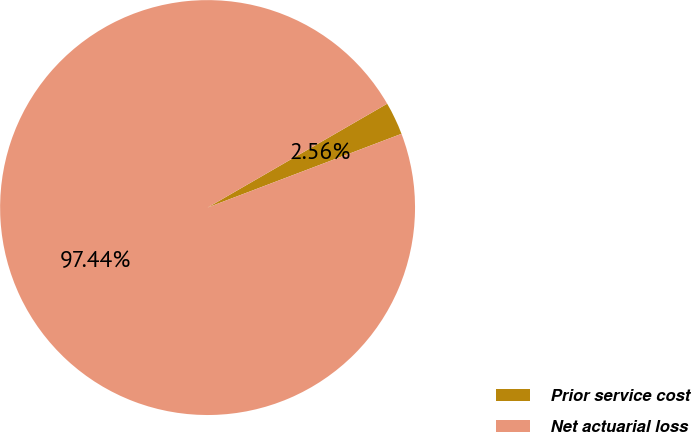<chart> <loc_0><loc_0><loc_500><loc_500><pie_chart><fcel>Prior service cost<fcel>Net actuarial loss<nl><fcel>2.56%<fcel>97.44%<nl></chart> 